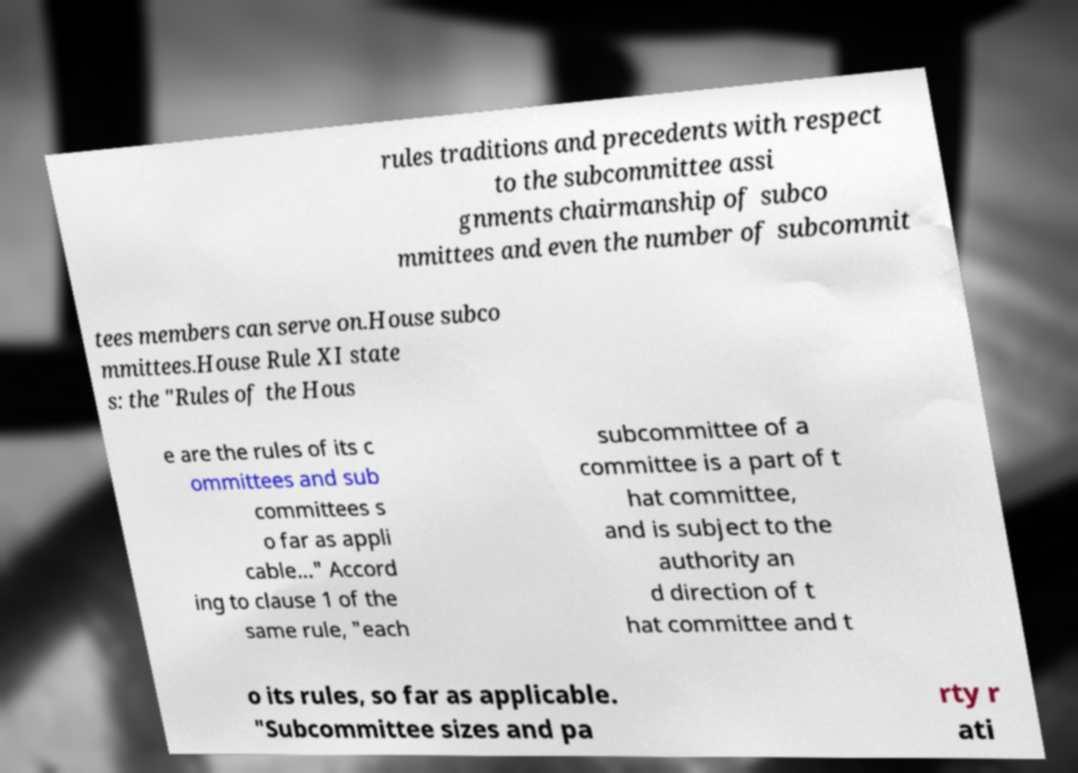Can you read and provide the text displayed in the image?This photo seems to have some interesting text. Can you extract and type it out for me? rules traditions and precedents with respect to the subcommittee assi gnments chairmanship of subco mmittees and even the number of subcommit tees members can serve on.House subco mmittees.House Rule XI state s: the "Rules of the Hous e are the rules of its c ommittees and sub committees s o far as appli cable..." Accord ing to clause 1 of the same rule, "each subcommittee of a committee is a part of t hat committee, and is subject to the authority an d direction of t hat committee and t o its rules, so far as applicable. "Subcommittee sizes and pa rty r ati 